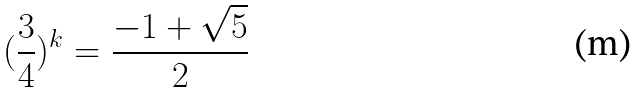Convert formula to latex. <formula><loc_0><loc_0><loc_500><loc_500>( \frac { 3 } { 4 } ) ^ { k } = \frac { - 1 + \sqrt { 5 } } { 2 }</formula> 